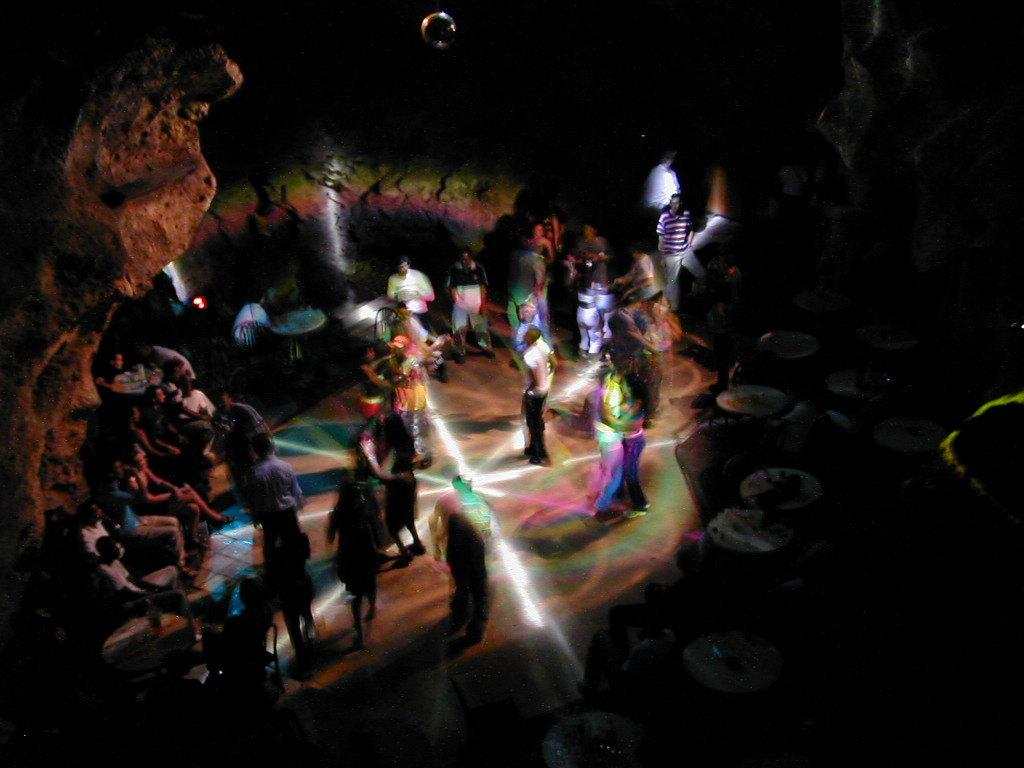Who or what can be seen in the image? There are people present in the image. What can be observed in the background or surrounding environment? There are lights visible in the image. Can you describe the setting or location depicted in the image? The image appears to depict a cave. What type of argument is taking place between the people in the image? There is no indication of an argument in the image; the people are simply present in the cave setting. 